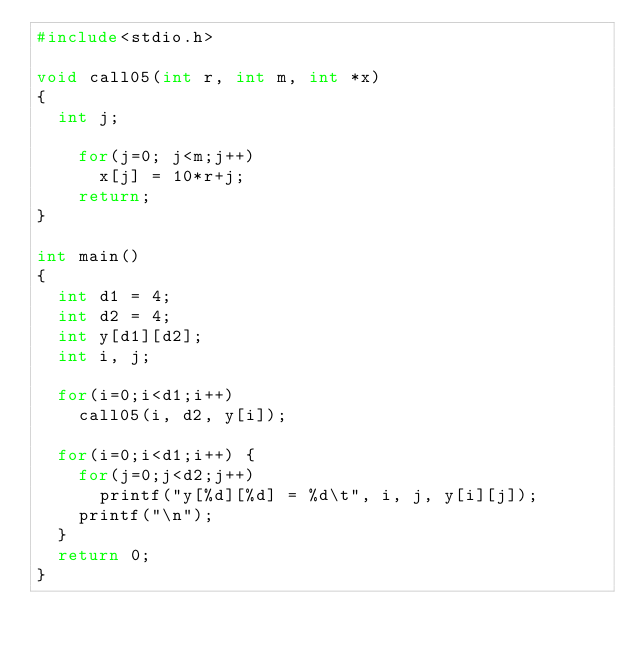Convert code to text. <code><loc_0><loc_0><loc_500><loc_500><_C_>#include<stdio.h> 

void call05(int r, int m, int *x)
{
  int j;

    for(j=0; j<m;j++)
      x[j] = 10*r+j;
    return;
}

int main()
{
  int d1 = 4;
  int d2 = 4;
  int y[d1][d2];
  int i, j;

  for(i=0;i<d1;i++)
    call05(i, d2, y[i]);

  for(i=0;i<d1;i++) {
    for(j=0;j<d2;j++)
      printf("y[%d][%d] = %d\t", i, j, y[i][j]);
    printf("\n");
  }
  return 0;
}
</code> 